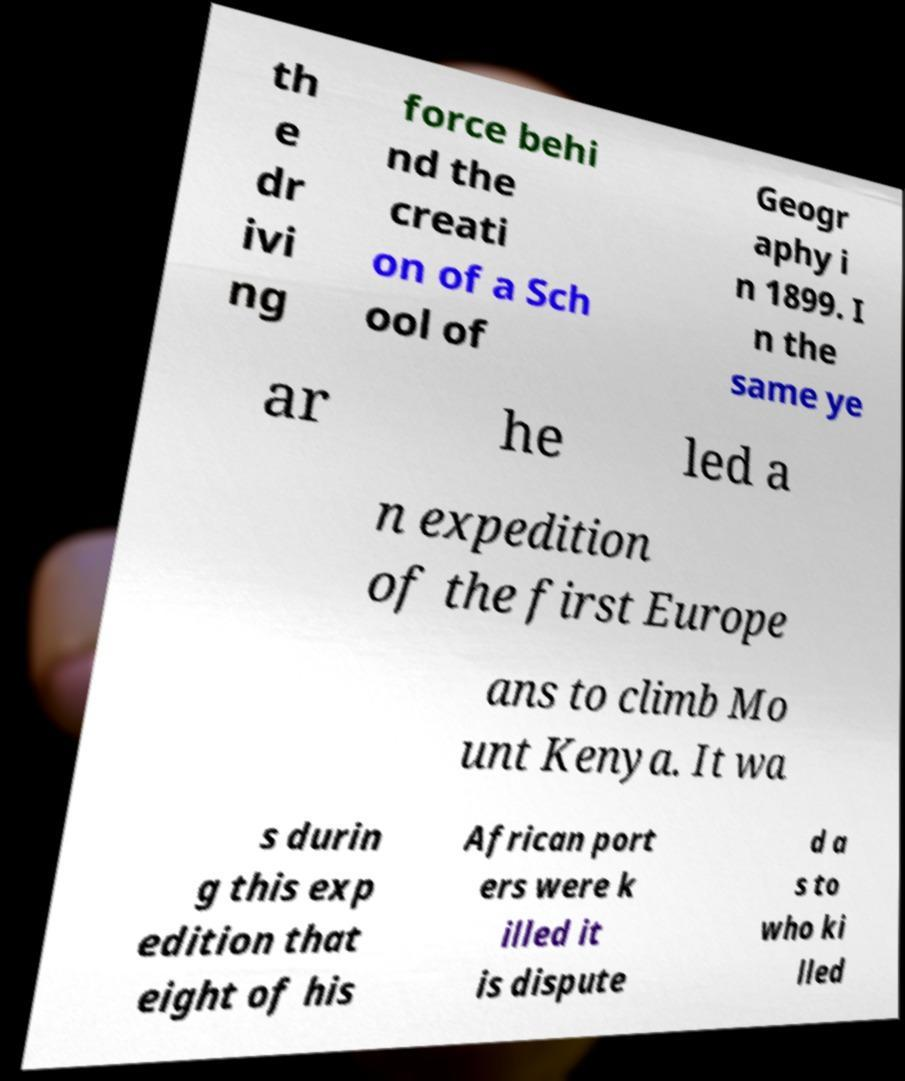Can you read and provide the text displayed in the image?This photo seems to have some interesting text. Can you extract and type it out for me? th e dr ivi ng force behi nd the creati on of a Sch ool of Geogr aphy i n 1899. I n the same ye ar he led a n expedition of the first Europe ans to climb Mo unt Kenya. It wa s durin g this exp edition that eight of his African port ers were k illed it is dispute d a s to who ki lled 